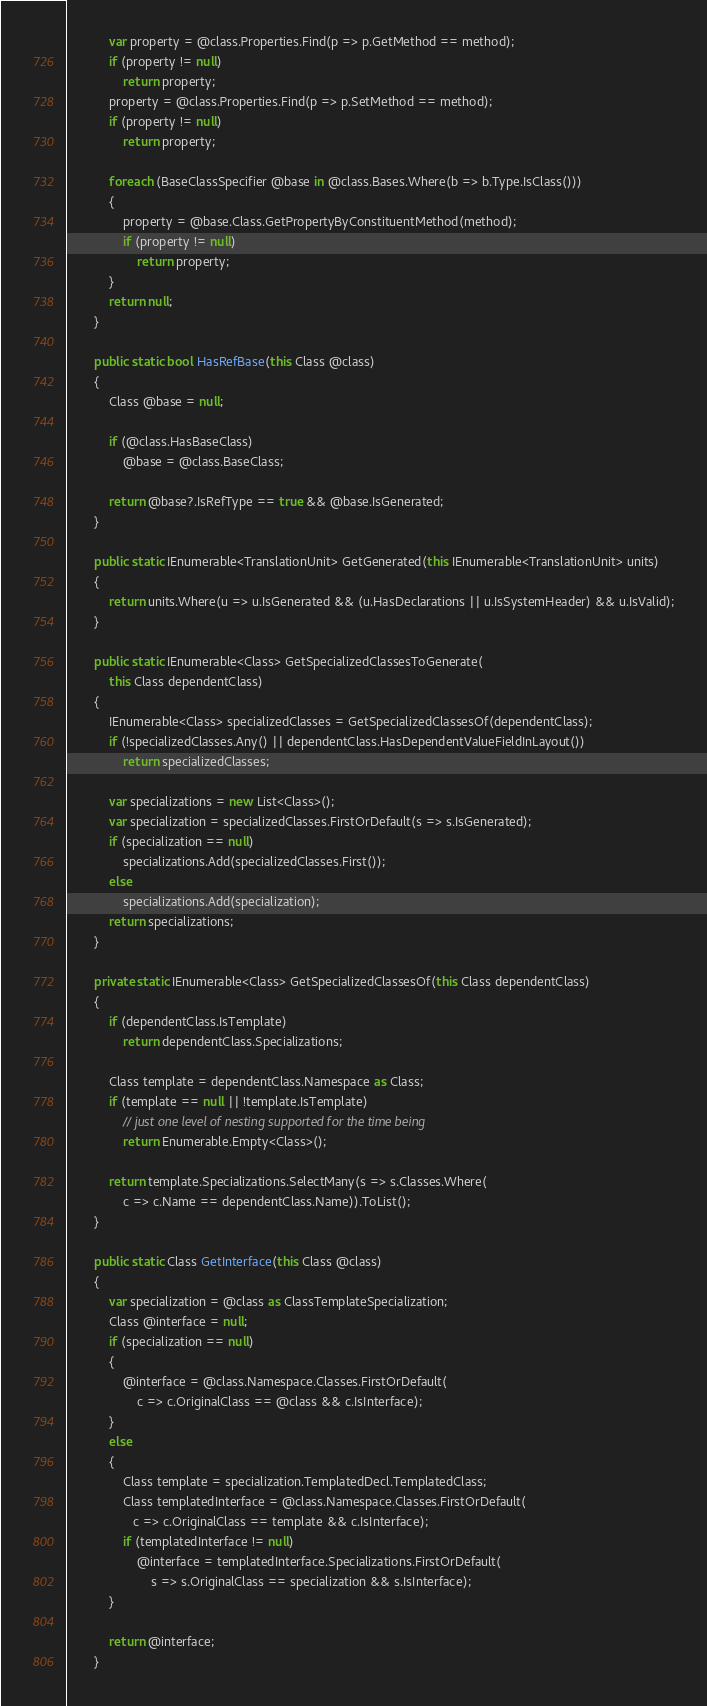<code> <loc_0><loc_0><loc_500><loc_500><_C#_>            var property = @class.Properties.Find(p => p.GetMethod == method);
            if (property != null)
                return property;
            property = @class.Properties.Find(p => p.SetMethod == method);
            if (property != null)
                return property;

            foreach (BaseClassSpecifier @base in @class.Bases.Where(b => b.Type.IsClass()))
            {
                property = @base.Class.GetPropertyByConstituentMethod(method);
                if (property != null)
                    return property;
            }
            return null;
        }

        public static bool HasRefBase(this Class @class)
        {
            Class @base = null;

            if (@class.HasBaseClass)
                @base = @class.BaseClass;

            return @base?.IsRefType == true && @base.IsGenerated;
        }

        public static IEnumerable<TranslationUnit> GetGenerated(this IEnumerable<TranslationUnit> units)
        {
            return units.Where(u => u.IsGenerated && (u.HasDeclarations || u.IsSystemHeader) && u.IsValid);
        }

        public static IEnumerable<Class> GetSpecializedClassesToGenerate(
            this Class dependentClass)
        {
            IEnumerable<Class> specializedClasses = GetSpecializedClassesOf(dependentClass);
            if (!specializedClasses.Any() || dependentClass.HasDependentValueFieldInLayout())
                return specializedClasses;

            var specializations = new List<Class>();
            var specialization = specializedClasses.FirstOrDefault(s => s.IsGenerated);
            if (specialization == null)
                specializations.Add(specializedClasses.First());
            else
                specializations.Add(specialization);
            return specializations;
        }

        private static IEnumerable<Class> GetSpecializedClassesOf(this Class dependentClass)
        {
            if (dependentClass.IsTemplate)
                return dependentClass.Specializations;

            Class template = dependentClass.Namespace as Class;
            if (template == null || !template.IsTemplate)
                // just one level of nesting supported for the time being
                return Enumerable.Empty<Class>();

            return template.Specializations.SelectMany(s => s.Classes.Where(
                c => c.Name == dependentClass.Name)).ToList();
        }

        public static Class GetInterface(this Class @class)
        {
            var specialization = @class as ClassTemplateSpecialization;
            Class @interface = null;
            if (specialization == null)
            {
                @interface = @class.Namespace.Classes.FirstOrDefault(
                    c => c.OriginalClass == @class && c.IsInterface);
            }
            else
            {
                Class template = specialization.TemplatedDecl.TemplatedClass;
                Class templatedInterface = @class.Namespace.Classes.FirstOrDefault(
                   c => c.OriginalClass == template && c.IsInterface);
                if (templatedInterface != null)
                    @interface = templatedInterface.Specializations.FirstOrDefault(
                        s => s.OriginalClass == specialization && s.IsInterface);
            }

            return @interface;
        }
</code> 